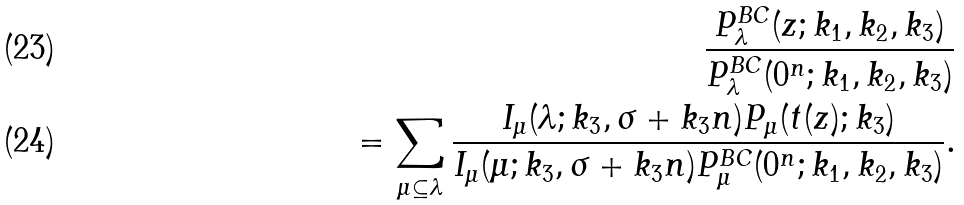<formula> <loc_0><loc_0><loc_500><loc_500>\frac { P ^ { B C } _ { \lambda } ( z ; k _ { 1 } , k _ { 2 } , k _ { 3 } ) } { P ^ { B C } _ { \lambda } ( 0 ^ { n } ; k _ { 1 } , k _ { 2 } , k _ { 3 } ) } \\ = \sum _ { \mu \subseteq \lambda } \frac { I _ { \mu } ( \lambda ; k _ { 3 } , \sigma + k _ { 3 } n ) P _ { \mu } ( t ( z ) ; k _ { 3 } ) } { I _ { \mu } ( \mu ; k _ { 3 } , \sigma + k _ { 3 } n ) P ^ { B C } _ { \mu } ( 0 ^ { n } ; k _ { 1 } , k _ { 2 } , k _ { 3 } ) } .</formula> 